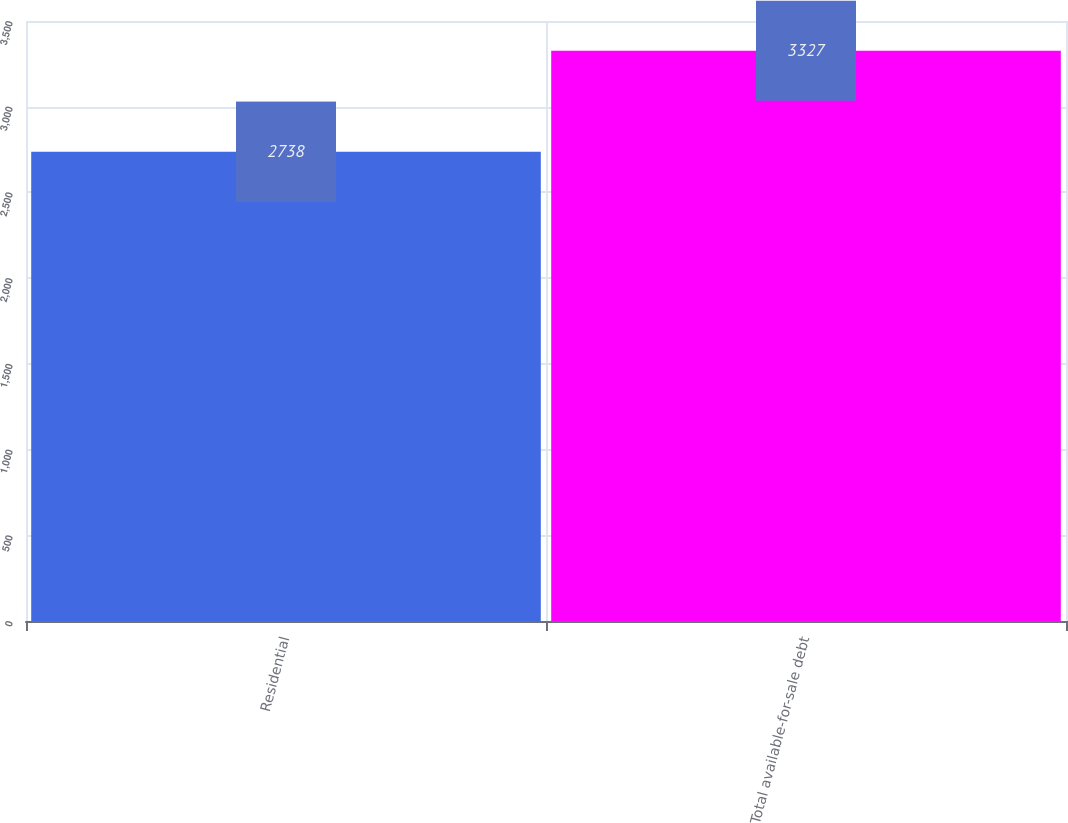<chart> <loc_0><loc_0><loc_500><loc_500><bar_chart><fcel>Residential<fcel>Total available-for-sale debt<nl><fcel>2738<fcel>3327<nl></chart> 